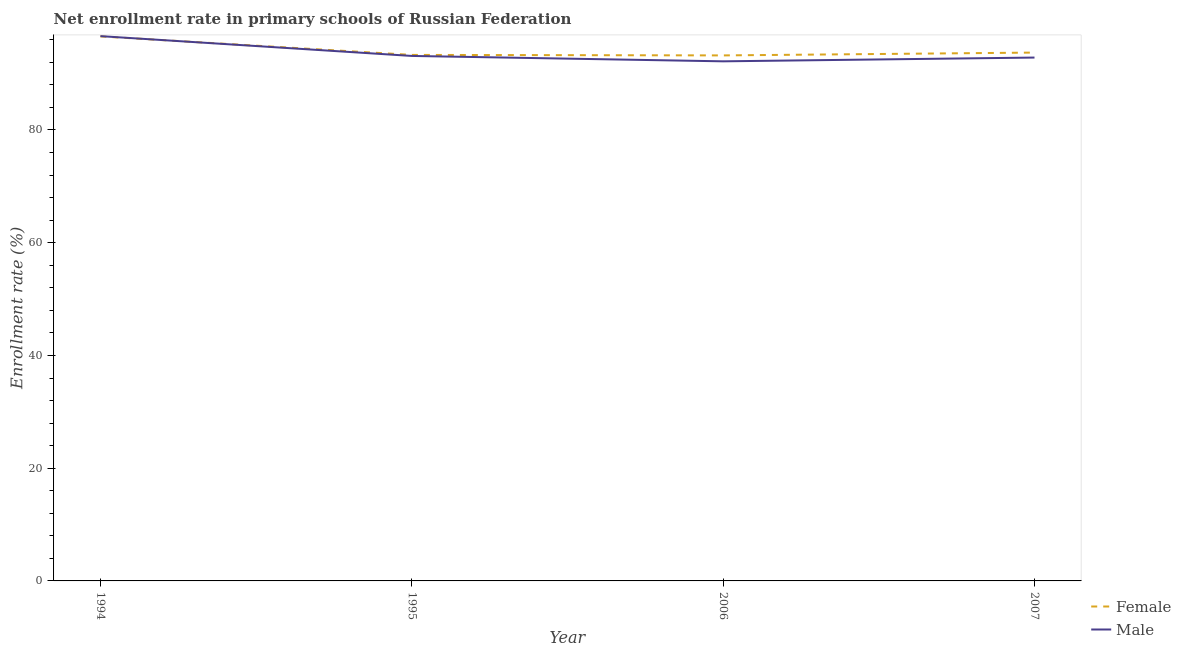Is the number of lines equal to the number of legend labels?
Your answer should be compact. Yes. What is the enrollment rate of male students in 1995?
Offer a very short reply. 93.14. Across all years, what is the maximum enrollment rate of female students?
Ensure brevity in your answer.  96.6. Across all years, what is the minimum enrollment rate of female students?
Your answer should be compact. 93.23. In which year was the enrollment rate of female students maximum?
Ensure brevity in your answer.  1994. What is the total enrollment rate of female students in the graph?
Keep it short and to the point. 376.89. What is the difference between the enrollment rate of female students in 1994 and that in 1995?
Your response must be concise. 3.28. What is the difference between the enrollment rate of female students in 1995 and the enrollment rate of male students in 2007?
Offer a terse response. 0.47. What is the average enrollment rate of female students per year?
Give a very brief answer. 94.22. In the year 2007, what is the difference between the enrollment rate of female students and enrollment rate of male students?
Provide a short and direct response. 0.88. In how many years, is the enrollment rate of female students greater than 48 %?
Make the answer very short. 4. What is the ratio of the enrollment rate of female students in 1994 to that in 2007?
Provide a succinct answer. 1.03. What is the difference between the highest and the second highest enrollment rate of male students?
Your response must be concise. 3.51. What is the difference between the highest and the lowest enrollment rate of female students?
Your answer should be compact. 3.37. Is the sum of the enrollment rate of female students in 1994 and 1995 greater than the maximum enrollment rate of male students across all years?
Your response must be concise. Yes. Does the enrollment rate of male students monotonically increase over the years?
Keep it short and to the point. No. How many lines are there?
Offer a very short reply. 2. How many years are there in the graph?
Make the answer very short. 4. What is the difference between two consecutive major ticks on the Y-axis?
Make the answer very short. 20. Does the graph contain grids?
Your response must be concise. No. How many legend labels are there?
Provide a short and direct response. 2. How are the legend labels stacked?
Keep it short and to the point. Vertical. What is the title of the graph?
Offer a terse response. Net enrollment rate in primary schools of Russian Federation. Does "Female population" appear as one of the legend labels in the graph?
Ensure brevity in your answer.  No. What is the label or title of the X-axis?
Offer a terse response. Year. What is the label or title of the Y-axis?
Your response must be concise. Enrollment rate (%). What is the Enrollment rate (%) in Female in 1994?
Your response must be concise. 96.6. What is the Enrollment rate (%) in Male in 1994?
Offer a terse response. 96.65. What is the Enrollment rate (%) in Female in 1995?
Your answer should be very brief. 93.32. What is the Enrollment rate (%) of Male in 1995?
Offer a very short reply. 93.14. What is the Enrollment rate (%) in Female in 2006?
Give a very brief answer. 93.23. What is the Enrollment rate (%) of Male in 2006?
Ensure brevity in your answer.  92.18. What is the Enrollment rate (%) in Female in 2007?
Your answer should be very brief. 93.73. What is the Enrollment rate (%) in Male in 2007?
Your response must be concise. 92.85. Across all years, what is the maximum Enrollment rate (%) in Female?
Offer a very short reply. 96.6. Across all years, what is the maximum Enrollment rate (%) of Male?
Ensure brevity in your answer.  96.65. Across all years, what is the minimum Enrollment rate (%) of Female?
Ensure brevity in your answer.  93.23. Across all years, what is the minimum Enrollment rate (%) of Male?
Ensure brevity in your answer.  92.18. What is the total Enrollment rate (%) of Female in the graph?
Make the answer very short. 376.89. What is the total Enrollment rate (%) of Male in the graph?
Ensure brevity in your answer.  374.83. What is the difference between the Enrollment rate (%) in Female in 1994 and that in 1995?
Your answer should be compact. 3.28. What is the difference between the Enrollment rate (%) in Male in 1994 and that in 1995?
Your response must be concise. 3.51. What is the difference between the Enrollment rate (%) in Female in 1994 and that in 2006?
Your answer should be very brief. 3.37. What is the difference between the Enrollment rate (%) of Male in 1994 and that in 2006?
Provide a succinct answer. 4.47. What is the difference between the Enrollment rate (%) in Female in 1994 and that in 2007?
Give a very brief answer. 2.87. What is the difference between the Enrollment rate (%) in Male in 1994 and that in 2007?
Your response must be concise. 3.8. What is the difference between the Enrollment rate (%) in Female in 1995 and that in 2006?
Your response must be concise. 0.09. What is the difference between the Enrollment rate (%) of Male in 1995 and that in 2006?
Provide a short and direct response. 0.96. What is the difference between the Enrollment rate (%) in Female in 1995 and that in 2007?
Offer a terse response. -0.41. What is the difference between the Enrollment rate (%) of Male in 1995 and that in 2007?
Provide a short and direct response. 0.29. What is the difference between the Enrollment rate (%) of Female in 2006 and that in 2007?
Keep it short and to the point. -0.5. What is the difference between the Enrollment rate (%) in Male in 2006 and that in 2007?
Make the answer very short. -0.67. What is the difference between the Enrollment rate (%) in Female in 1994 and the Enrollment rate (%) in Male in 1995?
Provide a succinct answer. 3.46. What is the difference between the Enrollment rate (%) in Female in 1994 and the Enrollment rate (%) in Male in 2006?
Keep it short and to the point. 4.42. What is the difference between the Enrollment rate (%) in Female in 1994 and the Enrollment rate (%) in Male in 2007?
Provide a succinct answer. 3.75. What is the difference between the Enrollment rate (%) in Female in 1995 and the Enrollment rate (%) in Male in 2006?
Offer a terse response. 1.14. What is the difference between the Enrollment rate (%) in Female in 1995 and the Enrollment rate (%) in Male in 2007?
Your answer should be very brief. 0.47. What is the difference between the Enrollment rate (%) in Female in 2006 and the Enrollment rate (%) in Male in 2007?
Your answer should be compact. 0.38. What is the average Enrollment rate (%) in Female per year?
Your answer should be very brief. 94.22. What is the average Enrollment rate (%) in Male per year?
Provide a short and direct response. 93.71. In the year 1994, what is the difference between the Enrollment rate (%) in Female and Enrollment rate (%) in Male?
Your answer should be very brief. -0.05. In the year 1995, what is the difference between the Enrollment rate (%) in Female and Enrollment rate (%) in Male?
Ensure brevity in your answer.  0.18. In the year 2006, what is the difference between the Enrollment rate (%) in Female and Enrollment rate (%) in Male?
Provide a succinct answer. 1.05. In the year 2007, what is the difference between the Enrollment rate (%) of Female and Enrollment rate (%) of Male?
Offer a terse response. 0.88. What is the ratio of the Enrollment rate (%) in Female in 1994 to that in 1995?
Offer a very short reply. 1.04. What is the ratio of the Enrollment rate (%) in Male in 1994 to that in 1995?
Keep it short and to the point. 1.04. What is the ratio of the Enrollment rate (%) of Female in 1994 to that in 2006?
Provide a short and direct response. 1.04. What is the ratio of the Enrollment rate (%) of Male in 1994 to that in 2006?
Your answer should be very brief. 1.05. What is the ratio of the Enrollment rate (%) in Female in 1994 to that in 2007?
Give a very brief answer. 1.03. What is the ratio of the Enrollment rate (%) of Male in 1994 to that in 2007?
Keep it short and to the point. 1.04. What is the ratio of the Enrollment rate (%) of Female in 1995 to that in 2006?
Your answer should be compact. 1. What is the ratio of the Enrollment rate (%) in Male in 1995 to that in 2006?
Keep it short and to the point. 1.01. What is the ratio of the Enrollment rate (%) of Female in 1995 to that in 2007?
Your answer should be compact. 1. What is the ratio of the Enrollment rate (%) in Male in 2006 to that in 2007?
Your answer should be very brief. 0.99. What is the difference between the highest and the second highest Enrollment rate (%) in Female?
Make the answer very short. 2.87. What is the difference between the highest and the second highest Enrollment rate (%) in Male?
Your answer should be very brief. 3.51. What is the difference between the highest and the lowest Enrollment rate (%) of Female?
Give a very brief answer. 3.37. What is the difference between the highest and the lowest Enrollment rate (%) in Male?
Your response must be concise. 4.47. 